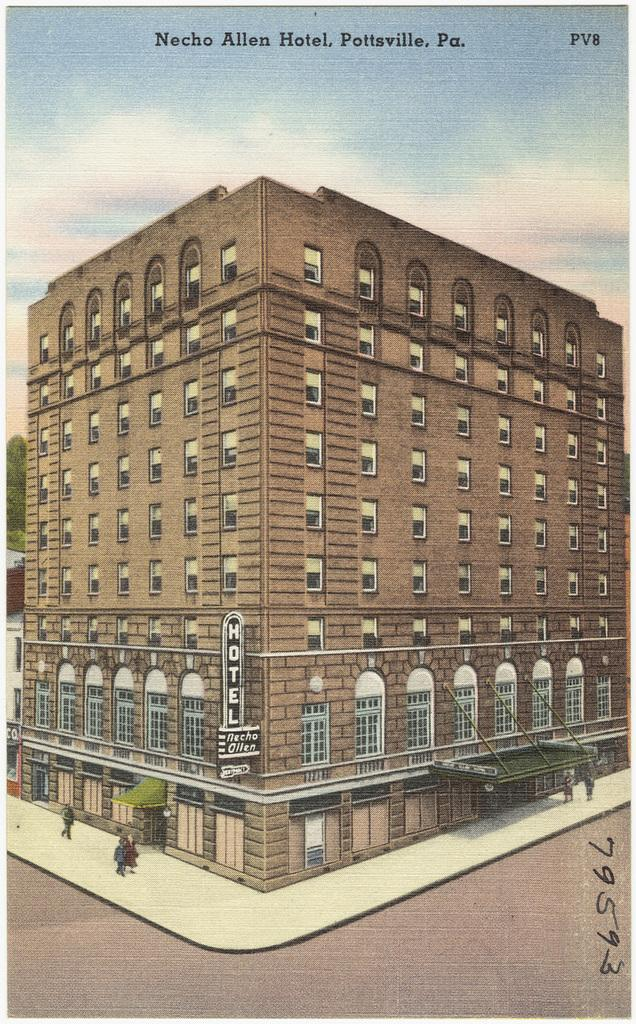What type of page is shown in the image? The image is a cover page. What is the main subject depicted on the cover page? There is a building depicted on the cover page. What type of observation can be made about the sound of the building in the image? There is no sound associated with the building in the image, so it is not possible to make any observations about it. 